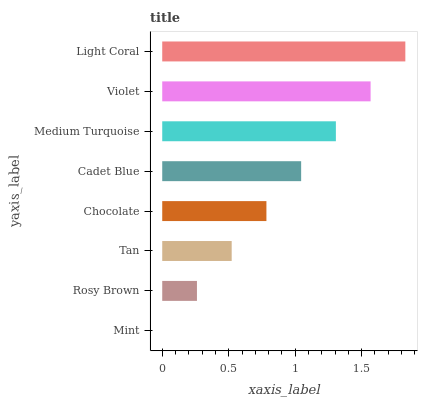Is Mint the minimum?
Answer yes or no. Yes. Is Light Coral the maximum?
Answer yes or no. Yes. Is Rosy Brown the minimum?
Answer yes or no. No. Is Rosy Brown the maximum?
Answer yes or no. No. Is Rosy Brown greater than Mint?
Answer yes or no. Yes. Is Mint less than Rosy Brown?
Answer yes or no. Yes. Is Mint greater than Rosy Brown?
Answer yes or no. No. Is Rosy Brown less than Mint?
Answer yes or no. No. Is Cadet Blue the high median?
Answer yes or no. Yes. Is Chocolate the low median?
Answer yes or no. Yes. Is Violet the high median?
Answer yes or no. No. Is Rosy Brown the low median?
Answer yes or no. No. 